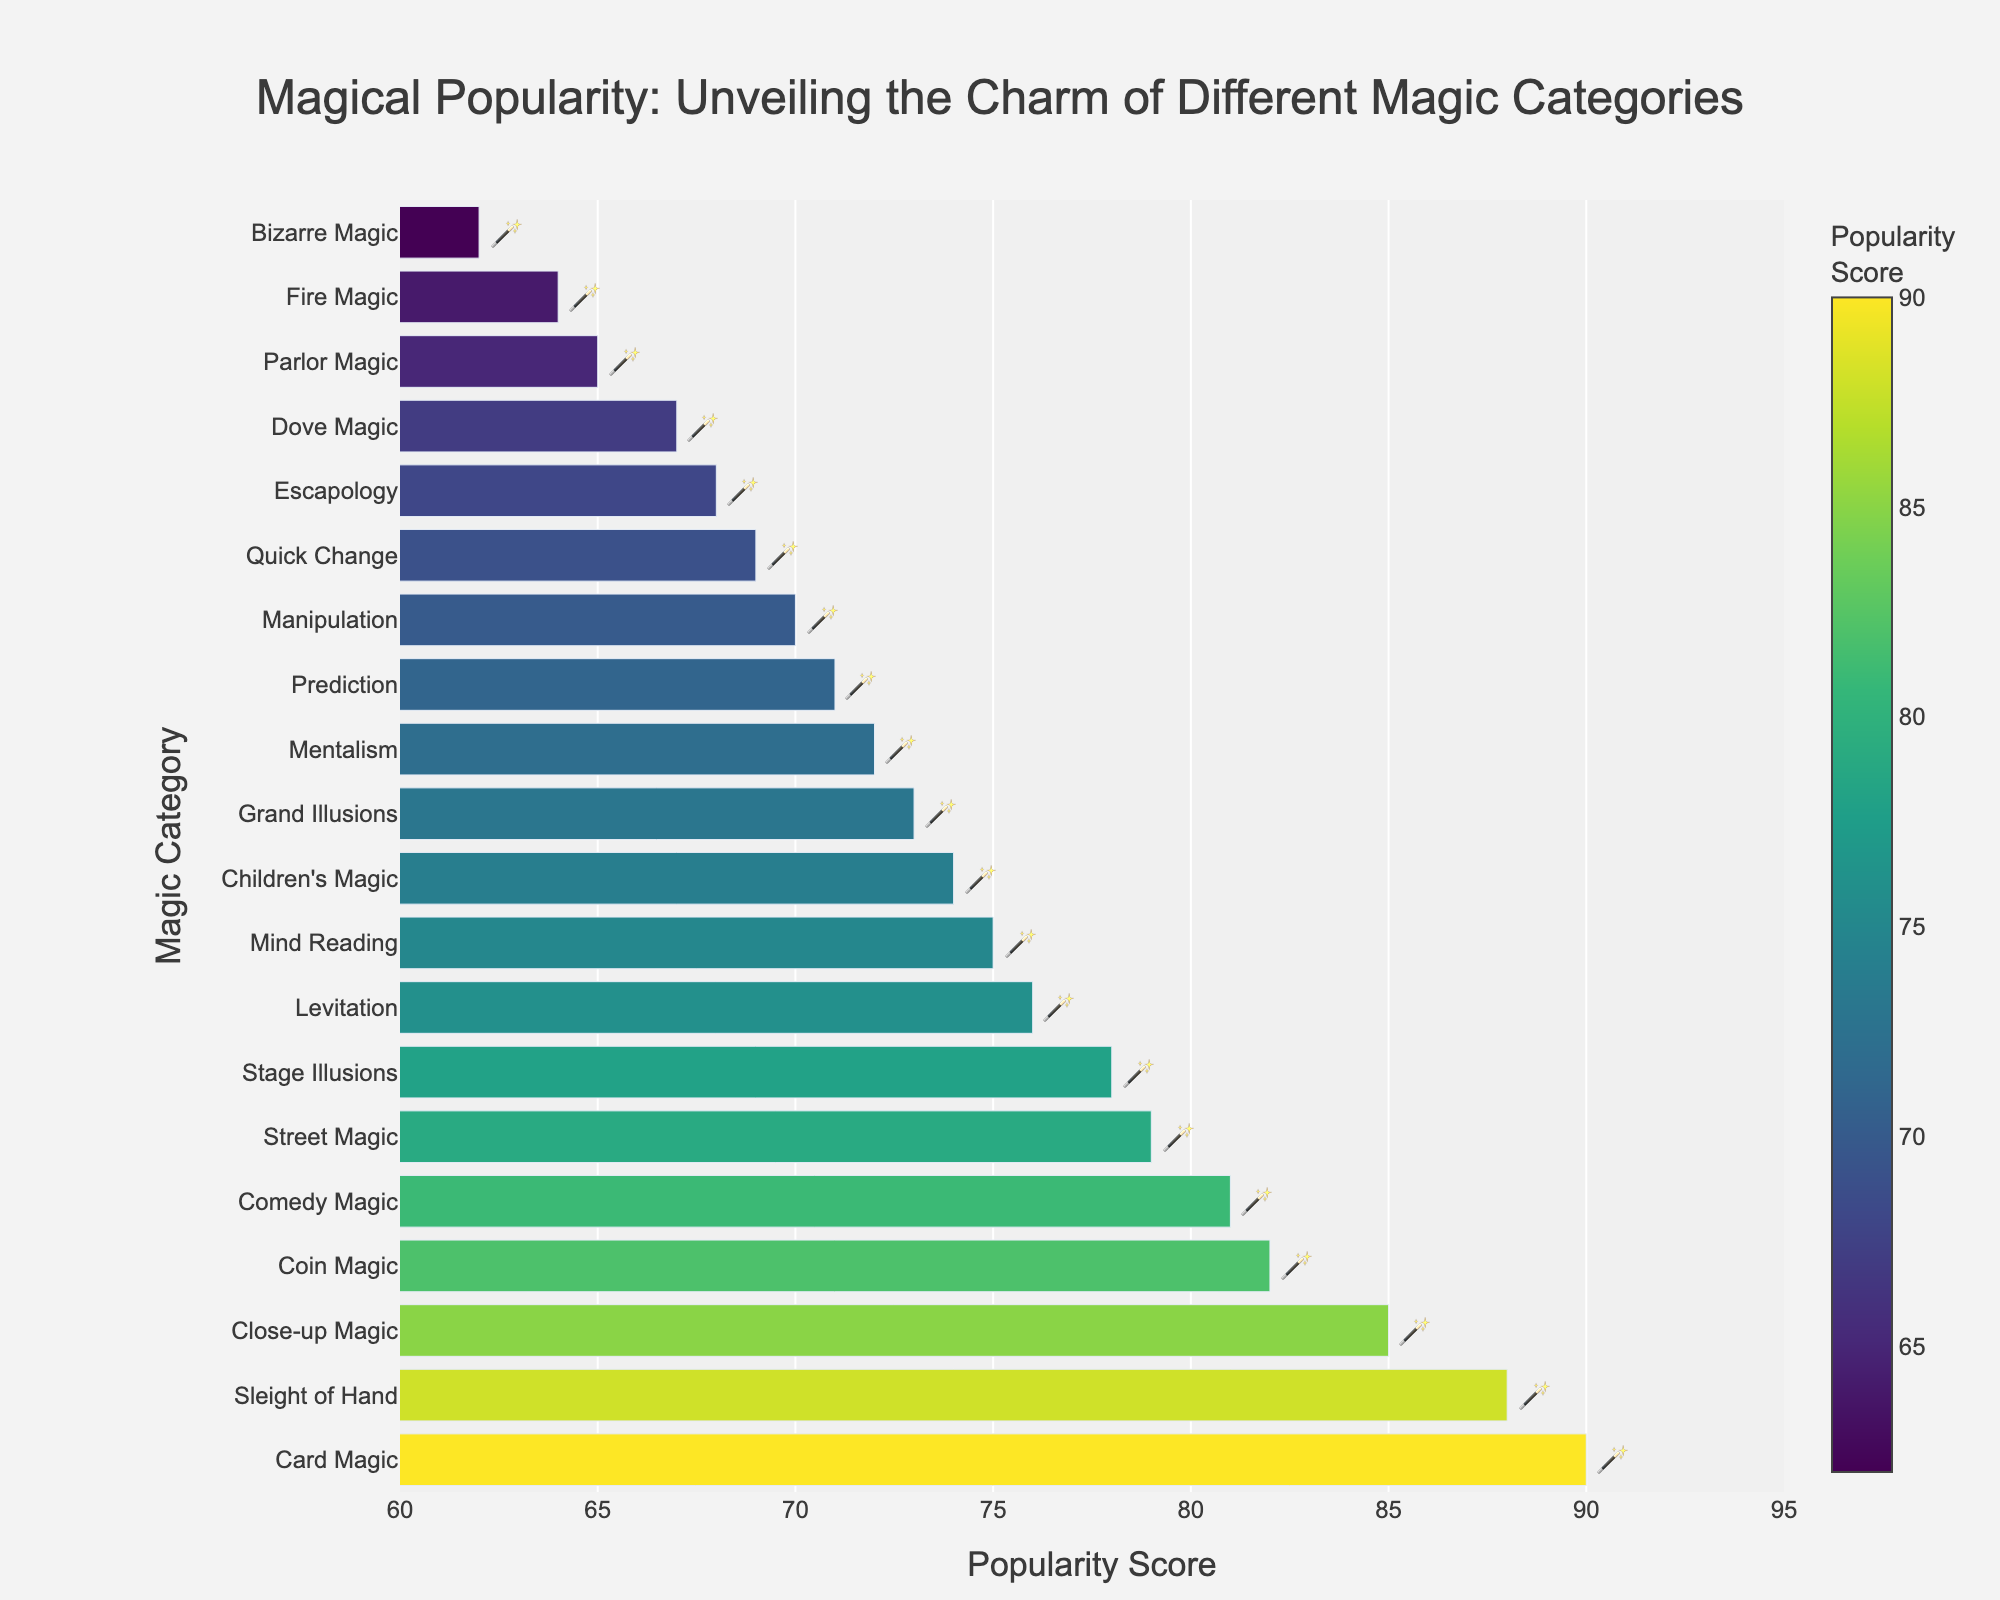Which magic category has the highest popularity score? The bar representing Card Magic is the longest and has the highest score.
Answer: Card Magic Which category has a higher popularity score: Coin Magic or Fire Magic? By comparing the lengths of the bars, Coin Magic is longer than Fire Magic.
Answer: Coin Magic List the magic categories with a popularity score of more than 80. The bars that are longer and exceed the score of 80 belong to Close-up Magic, Card Magic, Coin Magic, Comedy Magic, and Sleight of Hand.
Answer: Close-up Magic, Card Magic, Coin Magic, Comedy Magic, Sleight of Hand By how many points does Street Magic exceed Levitation in popularity? The popularity score of Street Magic is 79, and Levitation is 76. The difference is 79 - 76.
Answer: 3 What is the average popularity score of the top three most popular magic categories? The top three categories are Card Magic (90), Sleight of Hand (88), and Close-up Magic (85). The average is (90 + 88 + 85) / 3.
Answer: 87.67 Which magic categories have a popularity score between 70 and 75? The bars corresponding to the scores in this range are Mentalism, Grand Illusions, Prediction, Mind Reading, and Children's Magic.
Answer: Mentalism, Grand Illusions, Prediction, Mind Reading, Children's Magic How many magic categories have a popularity score of less than 70? The bars representing categories with scores less than 70 are Bizarre Magic (62), Fire Magic (64), Parlor Magic (65), Dove Magic (67), Escapology (68), and Quick Change (69).
Answer: 6 Which category ranks exactly in the middle (median) in terms of popularity score? With 20 categories, the median falls between the 10th and 11th ranked. The sorted categories show Children's Magic (74) and Mind Reading (75) in those positions. Therefore, the average is (74 + 75) / 2.
Answer: 74.5 What is the visual color indication for the category with the highest popularity score? The longest bar for Card Magic shows the brightest color in the Viridis colorscale used in the figure.
Answer: Brightest (yellow-green) 